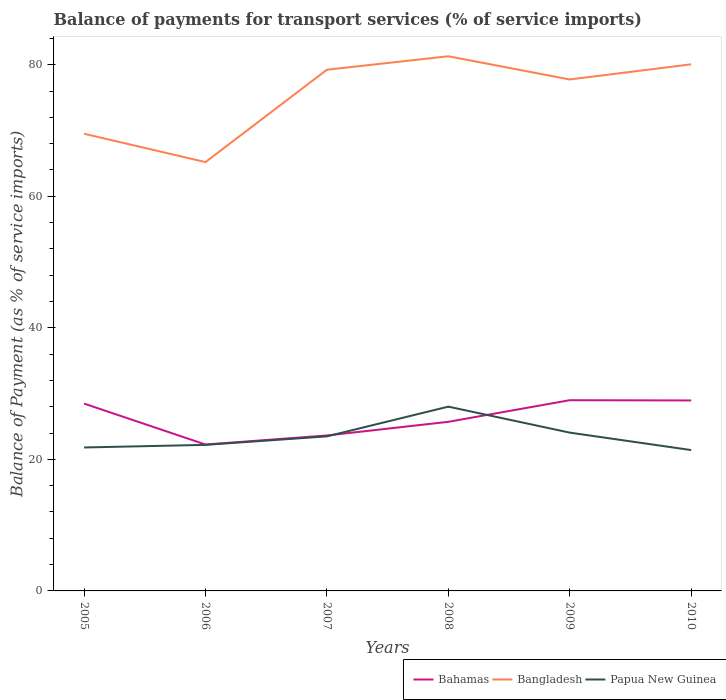Does the line corresponding to Bahamas intersect with the line corresponding to Papua New Guinea?
Offer a terse response. Yes. Is the number of lines equal to the number of legend labels?
Make the answer very short. Yes. Across all years, what is the maximum balance of payments for transport services in Bahamas?
Offer a terse response. 22.26. What is the total balance of payments for transport services in Bangladesh in the graph?
Provide a short and direct response. 4.31. What is the difference between the highest and the second highest balance of payments for transport services in Papua New Guinea?
Provide a succinct answer. 6.6. What is the difference between the highest and the lowest balance of payments for transport services in Bangladesh?
Offer a very short reply. 4. Is the balance of payments for transport services in Bangladesh strictly greater than the balance of payments for transport services in Papua New Guinea over the years?
Offer a very short reply. No. How many lines are there?
Provide a succinct answer. 3. How many years are there in the graph?
Make the answer very short. 6. Are the values on the major ticks of Y-axis written in scientific E-notation?
Your response must be concise. No. Where does the legend appear in the graph?
Offer a very short reply. Bottom right. How are the legend labels stacked?
Your answer should be compact. Horizontal. What is the title of the graph?
Make the answer very short. Balance of payments for transport services (% of service imports). What is the label or title of the X-axis?
Your answer should be compact. Years. What is the label or title of the Y-axis?
Make the answer very short. Balance of Payment (as % of service imports). What is the Balance of Payment (as % of service imports) of Bahamas in 2005?
Offer a terse response. 28.48. What is the Balance of Payment (as % of service imports) in Bangladesh in 2005?
Provide a short and direct response. 69.5. What is the Balance of Payment (as % of service imports) of Papua New Guinea in 2005?
Ensure brevity in your answer.  21.81. What is the Balance of Payment (as % of service imports) in Bahamas in 2006?
Your answer should be compact. 22.26. What is the Balance of Payment (as % of service imports) of Bangladesh in 2006?
Offer a very short reply. 65.2. What is the Balance of Payment (as % of service imports) of Papua New Guinea in 2006?
Offer a terse response. 22.2. What is the Balance of Payment (as % of service imports) of Bahamas in 2007?
Your answer should be compact. 23.63. What is the Balance of Payment (as % of service imports) in Bangladesh in 2007?
Your response must be concise. 79.24. What is the Balance of Payment (as % of service imports) of Papua New Guinea in 2007?
Give a very brief answer. 23.5. What is the Balance of Payment (as % of service imports) in Bahamas in 2008?
Keep it short and to the point. 25.71. What is the Balance of Payment (as % of service imports) in Bangladesh in 2008?
Your response must be concise. 81.29. What is the Balance of Payment (as % of service imports) in Papua New Guinea in 2008?
Your response must be concise. 28.02. What is the Balance of Payment (as % of service imports) in Bahamas in 2009?
Ensure brevity in your answer.  29. What is the Balance of Payment (as % of service imports) in Bangladesh in 2009?
Provide a succinct answer. 77.76. What is the Balance of Payment (as % of service imports) in Papua New Guinea in 2009?
Ensure brevity in your answer.  24.07. What is the Balance of Payment (as % of service imports) in Bahamas in 2010?
Keep it short and to the point. 28.96. What is the Balance of Payment (as % of service imports) in Bangladesh in 2010?
Make the answer very short. 80.06. What is the Balance of Payment (as % of service imports) in Papua New Guinea in 2010?
Your response must be concise. 21.41. Across all years, what is the maximum Balance of Payment (as % of service imports) in Bahamas?
Your answer should be very brief. 29. Across all years, what is the maximum Balance of Payment (as % of service imports) of Bangladesh?
Offer a very short reply. 81.29. Across all years, what is the maximum Balance of Payment (as % of service imports) of Papua New Guinea?
Give a very brief answer. 28.02. Across all years, what is the minimum Balance of Payment (as % of service imports) of Bahamas?
Offer a terse response. 22.26. Across all years, what is the minimum Balance of Payment (as % of service imports) in Bangladesh?
Give a very brief answer. 65.2. Across all years, what is the minimum Balance of Payment (as % of service imports) of Papua New Guinea?
Give a very brief answer. 21.41. What is the total Balance of Payment (as % of service imports) in Bahamas in the graph?
Make the answer very short. 158.03. What is the total Balance of Payment (as % of service imports) of Bangladesh in the graph?
Ensure brevity in your answer.  453.04. What is the total Balance of Payment (as % of service imports) in Papua New Guinea in the graph?
Your answer should be very brief. 141.01. What is the difference between the Balance of Payment (as % of service imports) of Bahamas in 2005 and that in 2006?
Ensure brevity in your answer.  6.22. What is the difference between the Balance of Payment (as % of service imports) in Bangladesh in 2005 and that in 2006?
Keep it short and to the point. 4.31. What is the difference between the Balance of Payment (as % of service imports) in Papua New Guinea in 2005 and that in 2006?
Your answer should be very brief. -0.4. What is the difference between the Balance of Payment (as % of service imports) of Bahamas in 2005 and that in 2007?
Your answer should be very brief. 4.85. What is the difference between the Balance of Payment (as % of service imports) of Bangladesh in 2005 and that in 2007?
Give a very brief answer. -9.74. What is the difference between the Balance of Payment (as % of service imports) in Papua New Guinea in 2005 and that in 2007?
Your answer should be compact. -1.69. What is the difference between the Balance of Payment (as % of service imports) in Bahamas in 2005 and that in 2008?
Keep it short and to the point. 2.77. What is the difference between the Balance of Payment (as % of service imports) of Bangladesh in 2005 and that in 2008?
Give a very brief answer. -11.78. What is the difference between the Balance of Payment (as % of service imports) in Papua New Guinea in 2005 and that in 2008?
Ensure brevity in your answer.  -6.21. What is the difference between the Balance of Payment (as % of service imports) in Bahamas in 2005 and that in 2009?
Ensure brevity in your answer.  -0.51. What is the difference between the Balance of Payment (as % of service imports) in Bangladesh in 2005 and that in 2009?
Your answer should be very brief. -8.25. What is the difference between the Balance of Payment (as % of service imports) in Papua New Guinea in 2005 and that in 2009?
Offer a terse response. -2.26. What is the difference between the Balance of Payment (as % of service imports) in Bahamas in 2005 and that in 2010?
Give a very brief answer. -0.48. What is the difference between the Balance of Payment (as % of service imports) in Bangladesh in 2005 and that in 2010?
Make the answer very short. -10.56. What is the difference between the Balance of Payment (as % of service imports) in Papua New Guinea in 2005 and that in 2010?
Your response must be concise. 0.39. What is the difference between the Balance of Payment (as % of service imports) of Bahamas in 2006 and that in 2007?
Offer a very short reply. -1.37. What is the difference between the Balance of Payment (as % of service imports) in Bangladesh in 2006 and that in 2007?
Provide a short and direct response. -14.04. What is the difference between the Balance of Payment (as % of service imports) in Papua New Guinea in 2006 and that in 2007?
Your answer should be compact. -1.29. What is the difference between the Balance of Payment (as % of service imports) in Bahamas in 2006 and that in 2008?
Offer a terse response. -3.45. What is the difference between the Balance of Payment (as % of service imports) of Bangladesh in 2006 and that in 2008?
Offer a terse response. -16.09. What is the difference between the Balance of Payment (as % of service imports) of Papua New Guinea in 2006 and that in 2008?
Keep it short and to the point. -5.81. What is the difference between the Balance of Payment (as % of service imports) of Bahamas in 2006 and that in 2009?
Your answer should be compact. -6.74. What is the difference between the Balance of Payment (as % of service imports) of Bangladesh in 2006 and that in 2009?
Your answer should be very brief. -12.56. What is the difference between the Balance of Payment (as % of service imports) of Papua New Guinea in 2006 and that in 2009?
Your answer should be very brief. -1.86. What is the difference between the Balance of Payment (as % of service imports) in Bahamas in 2006 and that in 2010?
Provide a succinct answer. -6.7. What is the difference between the Balance of Payment (as % of service imports) of Bangladesh in 2006 and that in 2010?
Offer a terse response. -14.86. What is the difference between the Balance of Payment (as % of service imports) of Papua New Guinea in 2006 and that in 2010?
Ensure brevity in your answer.  0.79. What is the difference between the Balance of Payment (as % of service imports) of Bahamas in 2007 and that in 2008?
Keep it short and to the point. -2.08. What is the difference between the Balance of Payment (as % of service imports) in Bangladesh in 2007 and that in 2008?
Your response must be concise. -2.05. What is the difference between the Balance of Payment (as % of service imports) of Papua New Guinea in 2007 and that in 2008?
Keep it short and to the point. -4.52. What is the difference between the Balance of Payment (as % of service imports) of Bahamas in 2007 and that in 2009?
Give a very brief answer. -5.36. What is the difference between the Balance of Payment (as % of service imports) of Bangladesh in 2007 and that in 2009?
Provide a short and direct response. 1.48. What is the difference between the Balance of Payment (as % of service imports) of Papua New Guinea in 2007 and that in 2009?
Your response must be concise. -0.57. What is the difference between the Balance of Payment (as % of service imports) of Bahamas in 2007 and that in 2010?
Give a very brief answer. -5.33. What is the difference between the Balance of Payment (as % of service imports) of Bangladesh in 2007 and that in 2010?
Your response must be concise. -0.82. What is the difference between the Balance of Payment (as % of service imports) of Papua New Guinea in 2007 and that in 2010?
Make the answer very short. 2.08. What is the difference between the Balance of Payment (as % of service imports) of Bahamas in 2008 and that in 2009?
Make the answer very short. -3.29. What is the difference between the Balance of Payment (as % of service imports) in Bangladesh in 2008 and that in 2009?
Provide a short and direct response. 3.53. What is the difference between the Balance of Payment (as % of service imports) of Papua New Guinea in 2008 and that in 2009?
Offer a very short reply. 3.95. What is the difference between the Balance of Payment (as % of service imports) of Bahamas in 2008 and that in 2010?
Ensure brevity in your answer.  -3.25. What is the difference between the Balance of Payment (as % of service imports) of Bangladesh in 2008 and that in 2010?
Ensure brevity in your answer.  1.22. What is the difference between the Balance of Payment (as % of service imports) of Papua New Guinea in 2008 and that in 2010?
Your answer should be compact. 6.6. What is the difference between the Balance of Payment (as % of service imports) in Bahamas in 2009 and that in 2010?
Make the answer very short. 0.04. What is the difference between the Balance of Payment (as % of service imports) in Bangladesh in 2009 and that in 2010?
Offer a very short reply. -2.3. What is the difference between the Balance of Payment (as % of service imports) in Papua New Guinea in 2009 and that in 2010?
Give a very brief answer. 2.65. What is the difference between the Balance of Payment (as % of service imports) in Bahamas in 2005 and the Balance of Payment (as % of service imports) in Bangladesh in 2006?
Provide a short and direct response. -36.71. What is the difference between the Balance of Payment (as % of service imports) in Bahamas in 2005 and the Balance of Payment (as % of service imports) in Papua New Guinea in 2006?
Provide a short and direct response. 6.28. What is the difference between the Balance of Payment (as % of service imports) in Bangladesh in 2005 and the Balance of Payment (as % of service imports) in Papua New Guinea in 2006?
Keep it short and to the point. 47.3. What is the difference between the Balance of Payment (as % of service imports) of Bahamas in 2005 and the Balance of Payment (as % of service imports) of Bangladesh in 2007?
Keep it short and to the point. -50.76. What is the difference between the Balance of Payment (as % of service imports) of Bahamas in 2005 and the Balance of Payment (as % of service imports) of Papua New Guinea in 2007?
Your answer should be very brief. 4.98. What is the difference between the Balance of Payment (as % of service imports) in Bangladesh in 2005 and the Balance of Payment (as % of service imports) in Papua New Guinea in 2007?
Give a very brief answer. 46.01. What is the difference between the Balance of Payment (as % of service imports) in Bahamas in 2005 and the Balance of Payment (as % of service imports) in Bangladesh in 2008?
Offer a very short reply. -52.8. What is the difference between the Balance of Payment (as % of service imports) in Bahamas in 2005 and the Balance of Payment (as % of service imports) in Papua New Guinea in 2008?
Offer a terse response. 0.46. What is the difference between the Balance of Payment (as % of service imports) in Bangladesh in 2005 and the Balance of Payment (as % of service imports) in Papua New Guinea in 2008?
Your answer should be very brief. 41.49. What is the difference between the Balance of Payment (as % of service imports) of Bahamas in 2005 and the Balance of Payment (as % of service imports) of Bangladesh in 2009?
Offer a very short reply. -49.28. What is the difference between the Balance of Payment (as % of service imports) of Bahamas in 2005 and the Balance of Payment (as % of service imports) of Papua New Guinea in 2009?
Your answer should be very brief. 4.41. What is the difference between the Balance of Payment (as % of service imports) in Bangladesh in 2005 and the Balance of Payment (as % of service imports) in Papua New Guinea in 2009?
Keep it short and to the point. 45.44. What is the difference between the Balance of Payment (as % of service imports) of Bahamas in 2005 and the Balance of Payment (as % of service imports) of Bangladesh in 2010?
Keep it short and to the point. -51.58. What is the difference between the Balance of Payment (as % of service imports) in Bahamas in 2005 and the Balance of Payment (as % of service imports) in Papua New Guinea in 2010?
Give a very brief answer. 7.07. What is the difference between the Balance of Payment (as % of service imports) in Bangladesh in 2005 and the Balance of Payment (as % of service imports) in Papua New Guinea in 2010?
Provide a succinct answer. 48.09. What is the difference between the Balance of Payment (as % of service imports) in Bahamas in 2006 and the Balance of Payment (as % of service imports) in Bangladesh in 2007?
Make the answer very short. -56.98. What is the difference between the Balance of Payment (as % of service imports) in Bahamas in 2006 and the Balance of Payment (as % of service imports) in Papua New Guinea in 2007?
Give a very brief answer. -1.24. What is the difference between the Balance of Payment (as % of service imports) in Bangladesh in 2006 and the Balance of Payment (as % of service imports) in Papua New Guinea in 2007?
Your answer should be very brief. 41.7. What is the difference between the Balance of Payment (as % of service imports) of Bahamas in 2006 and the Balance of Payment (as % of service imports) of Bangladesh in 2008?
Your answer should be compact. -59.03. What is the difference between the Balance of Payment (as % of service imports) of Bahamas in 2006 and the Balance of Payment (as % of service imports) of Papua New Guinea in 2008?
Make the answer very short. -5.76. What is the difference between the Balance of Payment (as % of service imports) of Bangladesh in 2006 and the Balance of Payment (as % of service imports) of Papua New Guinea in 2008?
Provide a short and direct response. 37.18. What is the difference between the Balance of Payment (as % of service imports) in Bahamas in 2006 and the Balance of Payment (as % of service imports) in Bangladesh in 2009?
Your answer should be compact. -55.5. What is the difference between the Balance of Payment (as % of service imports) in Bahamas in 2006 and the Balance of Payment (as % of service imports) in Papua New Guinea in 2009?
Your answer should be compact. -1.81. What is the difference between the Balance of Payment (as % of service imports) in Bangladesh in 2006 and the Balance of Payment (as % of service imports) in Papua New Guinea in 2009?
Give a very brief answer. 41.13. What is the difference between the Balance of Payment (as % of service imports) in Bahamas in 2006 and the Balance of Payment (as % of service imports) in Bangladesh in 2010?
Your answer should be very brief. -57.8. What is the difference between the Balance of Payment (as % of service imports) of Bahamas in 2006 and the Balance of Payment (as % of service imports) of Papua New Guinea in 2010?
Your response must be concise. 0.84. What is the difference between the Balance of Payment (as % of service imports) in Bangladesh in 2006 and the Balance of Payment (as % of service imports) in Papua New Guinea in 2010?
Ensure brevity in your answer.  43.78. What is the difference between the Balance of Payment (as % of service imports) of Bahamas in 2007 and the Balance of Payment (as % of service imports) of Bangladesh in 2008?
Keep it short and to the point. -57.65. What is the difference between the Balance of Payment (as % of service imports) of Bahamas in 2007 and the Balance of Payment (as % of service imports) of Papua New Guinea in 2008?
Your answer should be very brief. -4.39. What is the difference between the Balance of Payment (as % of service imports) in Bangladesh in 2007 and the Balance of Payment (as % of service imports) in Papua New Guinea in 2008?
Ensure brevity in your answer.  51.22. What is the difference between the Balance of Payment (as % of service imports) of Bahamas in 2007 and the Balance of Payment (as % of service imports) of Bangladesh in 2009?
Provide a succinct answer. -54.13. What is the difference between the Balance of Payment (as % of service imports) in Bahamas in 2007 and the Balance of Payment (as % of service imports) in Papua New Guinea in 2009?
Give a very brief answer. -0.44. What is the difference between the Balance of Payment (as % of service imports) in Bangladesh in 2007 and the Balance of Payment (as % of service imports) in Papua New Guinea in 2009?
Ensure brevity in your answer.  55.17. What is the difference between the Balance of Payment (as % of service imports) of Bahamas in 2007 and the Balance of Payment (as % of service imports) of Bangladesh in 2010?
Your answer should be very brief. -56.43. What is the difference between the Balance of Payment (as % of service imports) in Bahamas in 2007 and the Balance of Payment (as % of service imports) in Papua New Guinea in 2010?
Make the answer very short. 2.22. What is the difference between the Balance of Payment (as % of service imports) in Bangladesh in 2007 and the Balance of Payment (as % of service imports) in Papua New Guinea in 2010?
Offer a terse response. 57.83. What is the difference between the Balance of Payment (as % of service imports) of Bahamas in 2008 and the Balance of Payment (as % of service imports) of Bangladesh in 2009?
Give a very brief answer. -52.05. What is the difference between the Balance of Payment (as % of service imports) in Bahamas in 2008 and the Balance of Payment (as % of service imports) in Papua New Guinea in 2009?
Provide a short and direct response. 1.64. What is the difference between the Balance of Payment (as % of service imports) in Bangladesh in 2008 and the Balance of Payment (as % of service imports) in Papua New Guinea in 2009?
Ensure brevity in your answer.  57.22. What is the difference between the Balance of Payment (as % of service imports) of Bahamas in 2008 and the Balance of Payment (as % of service imports) of Bangladesh in 2010?
Give a very brief answer. -54.35. What is the difference between the Balance of Payment (as % of service imports) in Bahamas in 2008 and the Balance of Payment (as % of service imports) in Papua New Guinea in 2010?
Your answer should be very brief. 4.3. What is the difference between the Balance of Payment (as % of service imports) in Bangladesh in 2008 and the Balance of Payment (as % of service imports) in Papua New Guinea in 2010?
Provide a short and direct response. 59.87. What is the difference between the Balance of Payment (as % of service imports) of Bahamas in 2009 and the Balance of Payment (as % of service imports) of Bangladesh in 2010?
Your answer should be compact. -51.06. What is the difference between the Balance of Payment (as % of service imports) in Bahamas in 2009 and the Balance of Payment (as % of service imports) in Papua New Guinea in 2010?
Your answer should be very brief. 7.58. What is the difference between the Balance of Payment (as % of service imports) of Bangladesh in 2009 and the Balance of Payment (as % of service imports) of Papua New Guinea in 2010?
Offer a very short reply. 56.34. What is the average Balance of Payment (as % of service imports) of Bahamas per year?
Ensure brevity in your answer.  26.34. What is the average Balance of Payment (as % of service imports) of Bangladesh per year?
Your response must be concise. 75.51. What is the average Balance of Payment (as % of service imports) of Papua New Guinea per year?
Your answer should be compact. 23.5. In the year 2005, what is the difference between the Balance of Payment (as % of service imports) of Bahamas and Balance of Payment (as % of service imports) of Bangladesh?
Keep it short and to the point. -41.02. In the year 2005, what is the difference between the Balance of Payment (as % of service imports) of Bahamas and Balance of Payment (as % of service imports) of Papua New Guinea?
Give a very brief answer. 6.67. In the year 2005, what is the difference between the Balance of Payment (as % of service imports) of Bangladesh and Balance of Payment (as % of service imports) of Papua New Guinea?
Offer a terse response. 47.7. In the year 2006, what is the difference between the Balance of Payment (as % of service imports) in Bahamas and Balance of Payment (as % of service imports) in Bangladesh?
Your response must be concise. -42.94. In the year 2006, what is the difference between the Balance of Payment (as % of service imports) of Bahamas and Balance of Payment (as % of service imports) of Papua New Guinea?
Provide a succinct answer. 0.05. In the year 2006, what is the difference between the Balance of Payment (as % of service imports) of Bangladesh and Balance of Payment (as % of service imports) of Papua New Guinea?
Make the answer very short. 42.99. In the year 2007, what is the difference between the Balance of Payment (as % of service imports) in Bahamas and Balance of Payment (as % of service imports) in Bangladesh?
Your response must be concise. -55.61. In the year 2007, what is the difference between the Balance of Payment (as % of service imports) of Bahamas and Balance of Payment (as % of service imports) of Papua New Guinea?
Your response must be concise. 0.13. In the year 2007, what is the difference between the Balance of Payment (as % of service imports) of Bangladesh and Balance of Payment (as % of service imports) of Papua New Guinea?
Offer a very short reply. 55.74. In the year 2008, what is the difference between the Balance of Payment (as % of service imports) of Bahamas and Balance of Payment (as % of service imports) of Bangladesh?
Your response must be concise. -55.57. In the year 2008, what is the difference between the Balance of Payment (as % of service imports) of Bahamas and Balance of Payment (as % of service imports) of Papua New Guinea?
Ensure brevity in your answer.  -2.31. In the year 2008, what is the difference between the Balance of Payment (as % of service imports) in Bangladesh and Balance of Payment (as % of service imports) in Papua New Guinea?
Your answer should be compact. 53.27. In the year 2009, what is the difference between the Balance of Payment (as % of service imports) of Bahamas and Balance of Payment (as % of service imports) of Bangladesh?
Offer a terse response. -48.76. In the year 2009, what is the difference between the Balance of Payment (as % of service imports) in Bahamas and Balance of Payment (as % of service imports) in Papua New Guinea?
Keep it short and to the point. 4.93. In the year 2009, what is the difference between the Balance of Payment (as % of service imports) in Bangladesh and Balance of Payment (as % of service imports) in Papua New Guinea?
Provide a short and direct response. 53.69. In the year 2010, what is the difference between the Balance of Payment (as % of service imports) of Bahamas and Balance of Payment (as % of service imports) of Bangladesh?
Give a very brief answer. -51.1. In the year 2010, what is the difference between the Balance of Payment (as % of service imports) of Bahamas and Balance of Payment (as % of service imports) of Papua New Guinea?
Give a very brief answer. 7.54. In the year 2010, what is the difference between the Balance of Payment (as % of service imports) in Bangladesh and Balance of Payment (as % of service imports) in Papua New Guinea?
Your answer should be compact. 58.65. What is the ratio of the Balance of Payment (as % of service imports) in Bahamas in 2005 to that in 2006?
Your answer should be very brief. 1.28. What is the ratio of the Balance of Payment (as % of service imports) in Bangladesh in 2005 to that in 2006?
Ensure brevity in your answer.  1.07. What is the ratio of the Balance of Payment (as % of service imports) in Papua New Guinea in 2005 to that in 2006?
Provide a succinct answer. 0.98. What is the ratio of the Balance of Payment (as % of service imports) in Bahamas in 2005 to that in 2007?
Offer a terse response. 1.21. What is the ratio of the Balance of Payment (as % of service imports) of Bangladesh in 2005 to that in 2007?
Your response must be concise. 0.88. What is the ratio of the Balance of Payment (as % of service imports) in Papua New Guinea in 2005 to that in 2007?
Provide a succinct answer. 0.93. What is the ratio of the Balance of Payment (as % of service imports) in Bahamas in 2005 to that in 2008?
Your answer should be very brief. 1.11. What is the ratio of the Balance of Payment (as % of service imports) in Bangladesh in 2005 to that in 2008?
Offer a very short reply. 0.86. What is the ratio of the Balance of Payment (as % of service imports) in Papua New Guinea in 2005 to that in 2008?
Offer a terse response. 0.78. What is the ratio of the Balance of Payment (as % of service imports) in Bahamas in 2005 to that in 2009?
Your answer should be compact. 0.98. What is the ratio of the Balance of Payment (as % of service imports) of Bangladesh in 2005 to that in 2009?
Give a very brief answer. 0.89. What is the ratio of the Balance of Payment (as % of service imports) in Papua New Guinea in 2005 to that in 2009?
Offer a terse response. 0.91. What is the ratio of the Balance of Payment (as % of service imports) in Bahamas in 2005 to that in 2010?
Provide a succinct answer. 0.98. What is the ratio of the Balance of Payment (as % of service imports) in Bangladesh in 2005 to that in 2010?
Keep it short and to the point. 0.87. What is the ratio of the Balance of Payment (as % of service imports) in Papua New Guinea in 2005 to that in 2010?
Your answer should be compact. 1.02. What is the ratio of the Balance of Payment (as % of service imports) of Bahamas in 2006 to that in 2007?
Keep it short and to the point. 0.94. What is the ratio of the Balance of Payment (as % of service imports) of Bangladesh in 2006 to that in 2007?
Provide a short and direct response. 0.82. What is the ratio of the Balance of Payment (as % of service imports) in Papua New Guinea in 2006 to that in 2007?
Offer a very short reply. 0.94. What is the ratio of the Balance of Payment (as % of service imports) in Bahamas in 2006 to that in 2008?
Provide a short and direct response. 0.87. What is the ratio of the Balance of Payment (as % of service imports) of Bangladesh in 2006 to that in 2008?
Ensure brevity in your answer.  0.8. What is the ratio of the Balance of Payment (as % of service imports) of Papua New Guinea in 2006 to that in 2008?
Offer a very short reply. 0.79. What is the ratio of the Balance of Payment (as % of service imports) in Bahamas in 2006 to that in 2009?
Provide a succinct answer. 0.77. What is the ratio of the Balance of Payment (as % of service imports) of Bangladesh in 2006 to that in 2009?
Your answer should be compact. 0.84. What is the ratio of the Balance of Payment (as % of service imports) in Papua New Guinea in 2006 to that in 2009?
Provide a short and direct response. 0.92. What is the ratio of the Balance of Payment (as % of service imports) in Bahamas in 2006 to that in 2010?
Keep it short and to the point. 0.77. What is the ratio of the Balance of Payment (as % of service imports) in Bangladesh in 2006 to that in 2010?
Ensure brevity in your answer.  0.81. What is the ratio of the Balance of Payment (as % of service imports) of Papua New Guinea in 2006 to that in 2010?
Offer a very short reply. 1.04. What is the ratio of the Balance of Payment (as % of service imports) in Bahamas in 2007 to that in 2008?
Your response must be concise. 0.92. What is the ratio of the Balance of Payment (as % of service imports) of Bangladesh in 2007 to that in 2008?
Give a very brief answer. 0.97. What is the ratio of the Balance of Payment (as % of service imports) of Papua New Guinea in 2007 to that in 2008?
Provide a succinct answer. 0.84. What is the ratio of the Balance of Payment (as % of service imports) in Bahamas in 2007 to that in 2009?
Your answer should be compact. 0.81. What is the ratio of the Balance of Payment (as % of service imports) of Bangladesh in 2007 to that in 2009?
Provide a succinct answer. 1.02. What is the ratio of the Balance of Payment (as % of service imports) of Papua New Guinea in 2007 to that in 2009?
Provide a succinct answer. 0.98. What is the ratio of the Balance of Payment (as % of service imports) of Bahamas in 2007 to that in 2010?
Ensure brevity in your answer.  0.82. What is the ratio of the Balance of Payment (as % of service imports) in Bangladesh in 2007 to that in 2010?
Your answer should be very brief. 0.99. What is the ratio of the Balance of Payment (as % of service imports) in Papua New Guinea in 2007 to that in 2010?
Give a very brief answer. 1.1. What is the ratio of the Balance of Payment (as % of service imports) of Bahamas in 2008 to that in 2009?
Offer a terse response. 0.89. What is the ratio of the Balance of Payment (as % of service imports) of Bangladesh in 2008 to that in 2009?
Offer a terse response. 1.05. What is the ratio of the Balance of Payment (as % of service imports) in Papua New Guinea in 2008 to that in 2009?
Give a very brief answer. 1.16. What is the ratio of the Balance of Payment (as % of service imports) in Bahamas in 2008 to that in 2010?
Provide a short and direct response. 0.89. What is the ratio of the Balance of Payment (as % of service imports) of Bangladesh in 2008 to that in 2010?
Your response must be concise. 1.02. What is the ratio of the Balance of Payment (as % of service imports) in Papua New Guinea in 2008 to that in 2010?
Keep it short and to the point. 1.31. What is the ratio of the Balance of Payment (as % of service imports) in Bangladesh in 2009 to that in 2010?
Your answer should be compact. 0.97. What is the ratio of the Balance of Payment (as % of service imports) of Papua New Guinea in 2009 to that in 2010?
Your answer should be very brief. 1.12. What is the difference between the highest and the second highest Balance of Payment (as % of service imports) of Bahamas?
Offer a terse response. 0.04. What is the difference between the highest and the second highest Balance of Payment (as % of service imports) of Bangladesh?
Keep it short and to the point. 1.22. What is the difference between the highest and the second highest Balance of Payment (as % of service imports) of Papua New Guinea?
Offer a very short reply. 3.95. What is the difference between the highest and the lowest Balance of Payment (as % of service imports) of Bahamas?
Your answer should be compact. 6.74. What is the difference between the highest and the lowest Balance of Payment (as % of service imports) in Bangladesh?
Your answer should be compact. 16.09. What is the difference between the highest and the lowest Balance of Payment (as % of service imports) in Papua New Guinea?
Your answer should be compact. 6.6. 